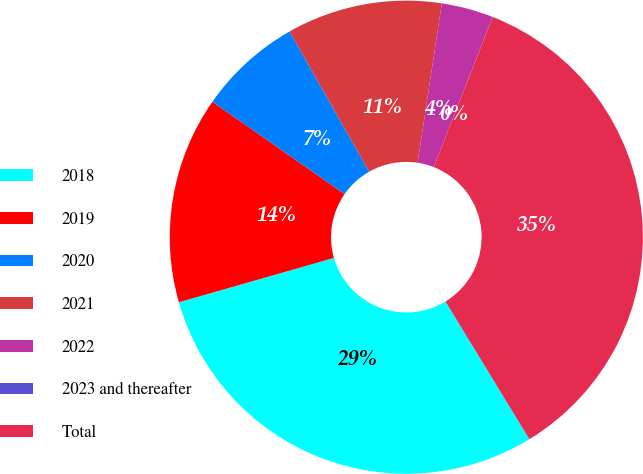Convert chart to OTSL. <chart><loc_0><loc_0><loc_500><loc_500><pie_chart><fcel>2018<fcel>2019<fcel>2020<fcel>2021<fcel>2022<fcel>2023 and thereafter<fcel>Total<nl><fcel>29.27%<fcel>14.14%<fcel>7.08%<fcel>10.61%<fcel>3.54%<fcel>0.01%<fcel>35.34%<nl></chart> 